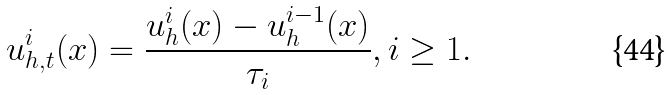Convert formula to latex. <formula><loc_0><loc_0><loc_500><loc_500>u _ { h , t } ^ { i } ( x ) = \frac { u _ { h } ^ { i } ( x ) - u _ { h } ^ { i - 1 } ( x ) } { \tau _ { i } } , i \geq 1 .</formula> 